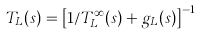Convert formula to latex. <formula><loc_0><loc_0><loc_500><loc_500>T _ { L } ( s ) = \left [ 1 / T _ { L } ^ { \infty } ( s ) + g _ { L } ( s ) \right ] ^ { - 1 }</formula> 